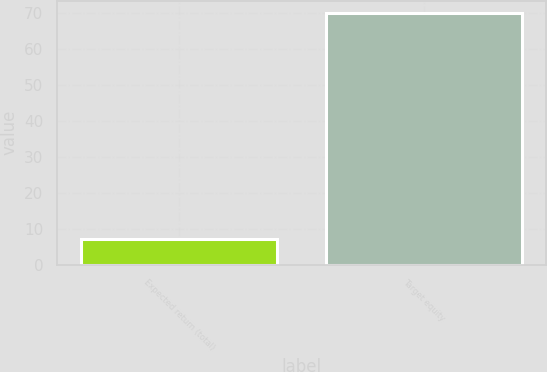<chart> <loc_0><loc_0><loc_500><loc_500><bar_chart><fcel>Expected return (total)<fcel>Target equity<nl><fcel>7<fcel>70<nl></chart> 